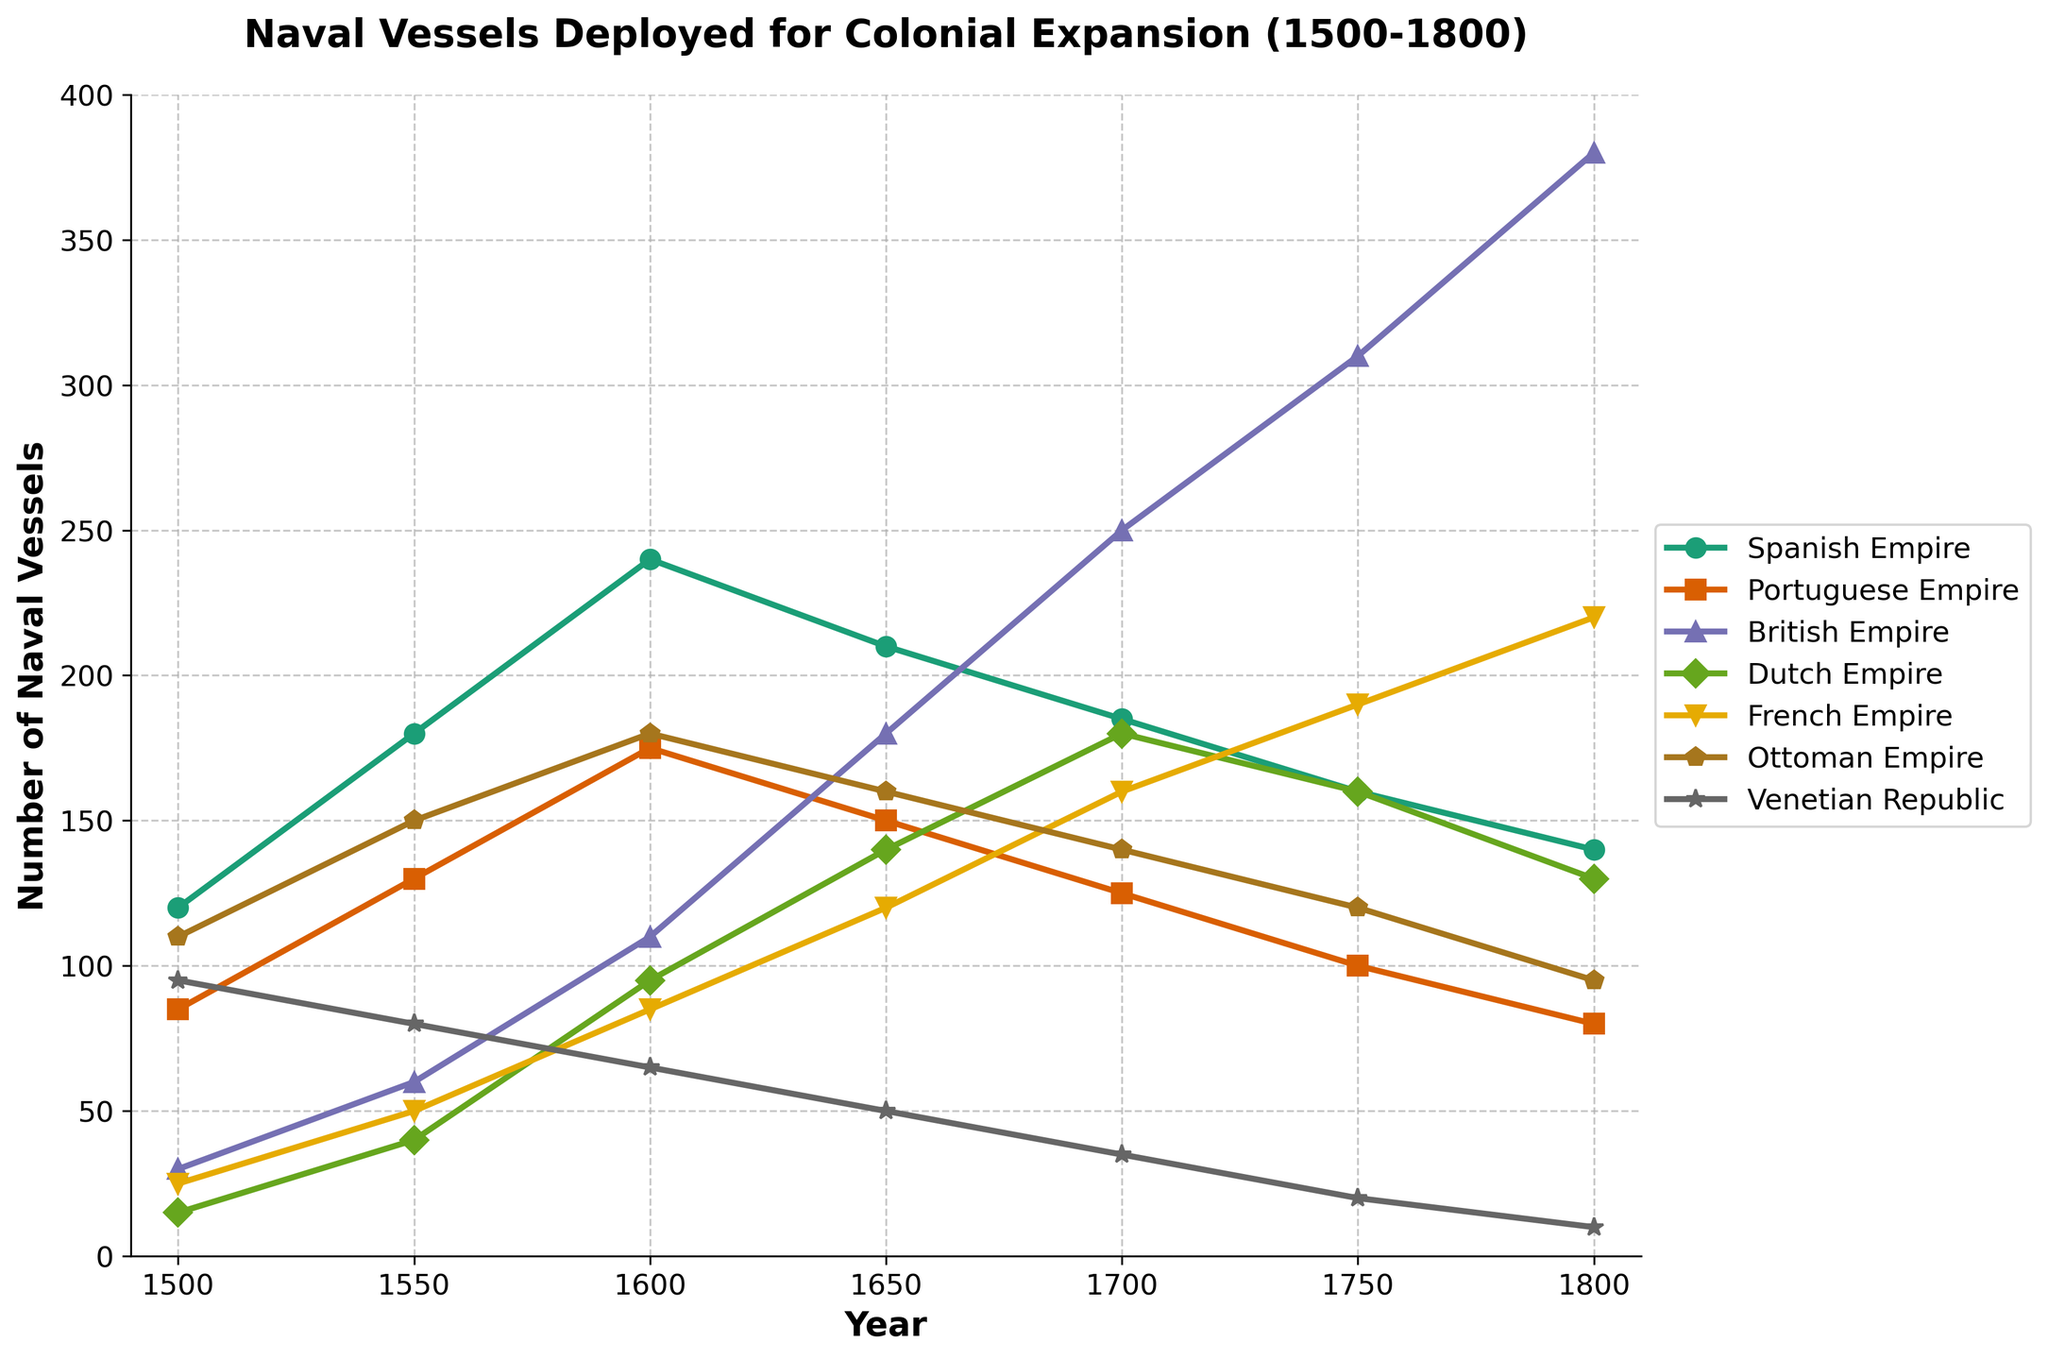Which empire deployed the most naval vessels in 1800? Refer to the data points in the figure for the year 1800. The British Empire had the highest number of naval vessels at 380.
Answer: British Empire Among the Spanish, Portuguese, and Ottoman Empires, which had the greatest decline in naval vessels from 1500 to 1800? Calculate the difference in naval vessels between 1500 and 1800 for the Spanish, Portuguese, and Ottoman Empires. The differences are 120-140=-20 (Spanish), 85-80=5 (Portuguese), and 110-95=15 (Ottoman), making the Spanish Empire the one with the greatest decline.
Answer: Spanish Empire Between which years did the British Empire see its largest increase in naval vessels? Look at the gradient of the British Empire line between each pair of consecutive years - 1700 to 1750 holds the largest increase, as the vessels went from 250 to 310, a difference of 60.
Answer: 1700 to 1750 Which empires experienced a consistent decrease in the number of naval vessels deployed over the given period? Examine the trend lines for each empire. The Venetian Republic is the only one showing a consistent decrease from 95 in 1500 to 10 in 1800.
Answer: Venetian Republic In 1650, which empire had the fewest naval vessels, and how many did it have? Check the data points for the year 1650, where the Dutch Empire had the fewest vessels with 140.
Answer: Dutch Empire, 140 What is the combined total of naval vessels deployed by the British and French Empires in 1700? Add the number of vessels for the British Empire (250) and the French Empire (160) in 1700. The total is 250 + 160 = 410.
Answer: 410 By what percentage did the British Empire increase its naval vessels from 1550 to 1650? Calculate the percentage increase: (180 - 60) / 60 * 100 = 200%.
Answer: 200% Which two empires had similar numbers of naval vessels in 1750, and what were their counts? Compare the data points for 1750. The Spanish and Dutch Empires had similar numbers with 160 vessels each.
Answer: Spanish Empire and Dutch Empire, 160 During which half-century did the Ottoman Empire experience the largest decrease in naval vessels? The largest decrease for the Ottoman Empire occurred between 1750 and 1800, with a 25-vessel decrease (120 to 95).
Answer: 1750 to 1800 What is the average number of naval vessels deployed by the French Empire across the recorded periods? The values for the French Empire are 25, 50, 85, 120, 160, 190, and 220. Sum these values (850) and divide by 7 to get the average: 850 / 7 ≈ 121.43.
Answer: Approximately 121.43 